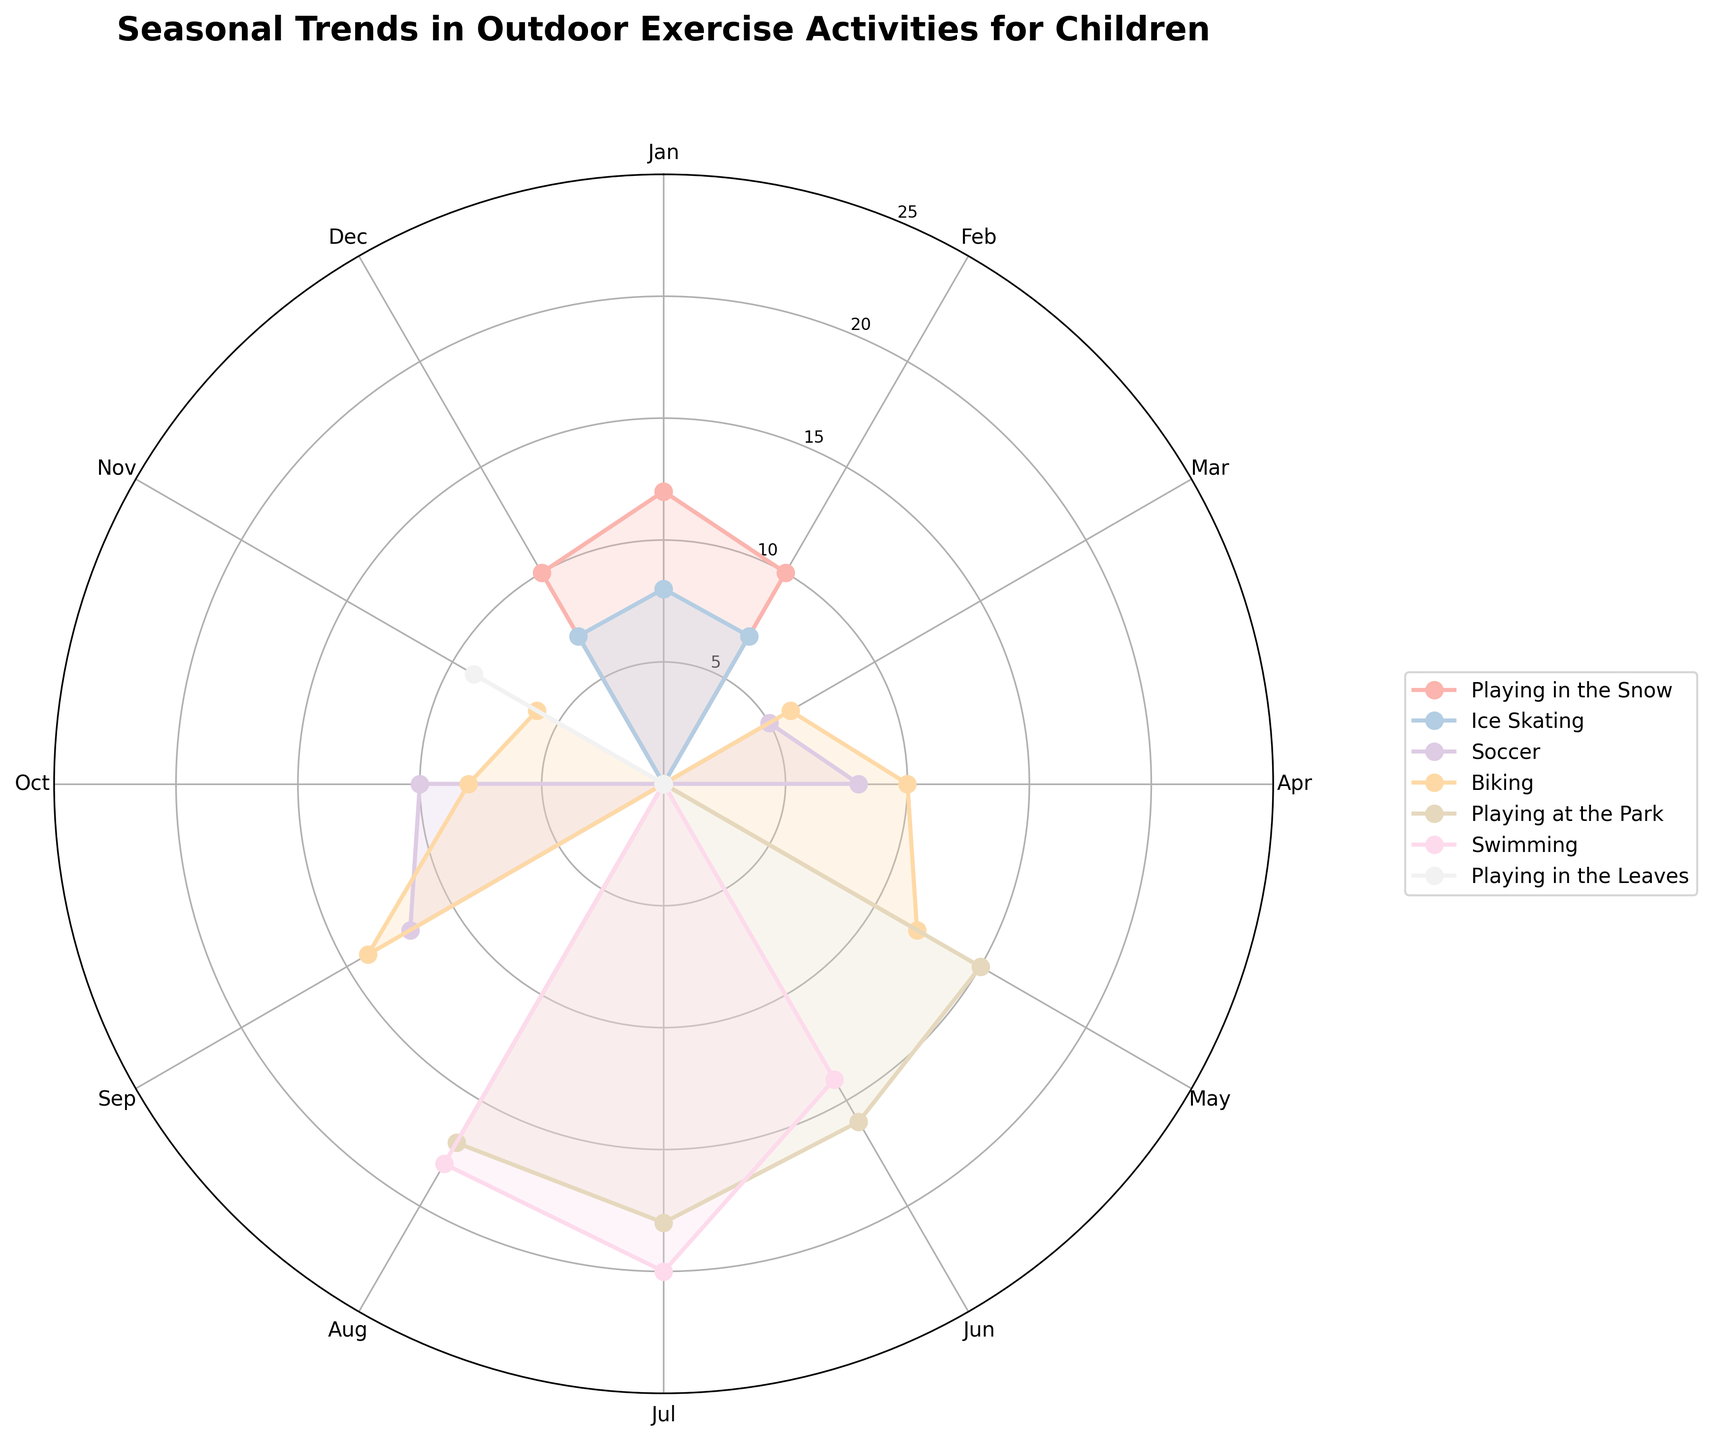What is the title of the figure? The title is usually displayed at the top of the figure. It provides a general overview of the content being visualized.
Answer: Seasonal Trends in Outdoor Exercise Activities for Children Which activity has the highest frequency in July? To find this, look for the activities listed around the July axis and identify which line extends the furthest.
Answer: Swimming How many different activities are displayed in the figure? Count the number of different activity labels in the legend.
Answer: 7 In which month is "Playing in the Snow" most frequent? Look around the monthly axes for "Playing in the Snow" and see where the corresponding line extends the furthest.
Answer: January Which two months have the highest frequencies for "Playing at the Park"? Look at the line for "Playing at the Park" and identify the two outermost points, corresponding to the specific months.
Answer: June and July Does any activity occur every month? Check the legend to see if any activity lines have points extending around the entire circle.
Answer: No Compare Swimming and Soccer, which has more months with maximum frequencies above 10? Look at the lines for both Swimming and Soccer and count the months where their points exceed the inner circle labeled 10.
Answer: Swimming What is the average frequency of "Soccer" in March, April, September, and October? Identify the values for Soccer in these months from the graph, sum them and divide by the number of months. Calculation: (5 + 8 + 12 + 10) / 4 = 35 / 4
Answer: 8.75 Which activity is represented by the color closest to pink in the figure? Compare the colors of the activity lines to the typical pastel pink shade.
Answer: Playing in the Snow What trend can you observe for "Biking" throughout the year? Observe the line for "Biking" and describe the pattern of frequency changes as it moves around the months.
Answer: Peaks in April and September, lower in winter months 